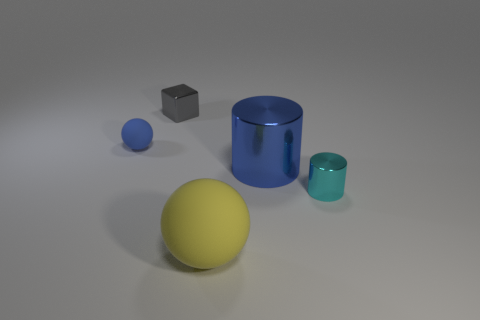Add 1 large purple rubber balls. How many objects exist? 6 Subtract all cylinders. How many objects are left? 3 Subtract all tiny gray metallic cubes. Subtract all small blue metal objects. How many objects are left? 4 Add 4 blue matte things. How many blue matte things are left? 5 Add 1 big gray rubber cylinders. How many big gray rubber cylinders exist? 1 Subtract 0 red cubes. How many objects are left? 5 